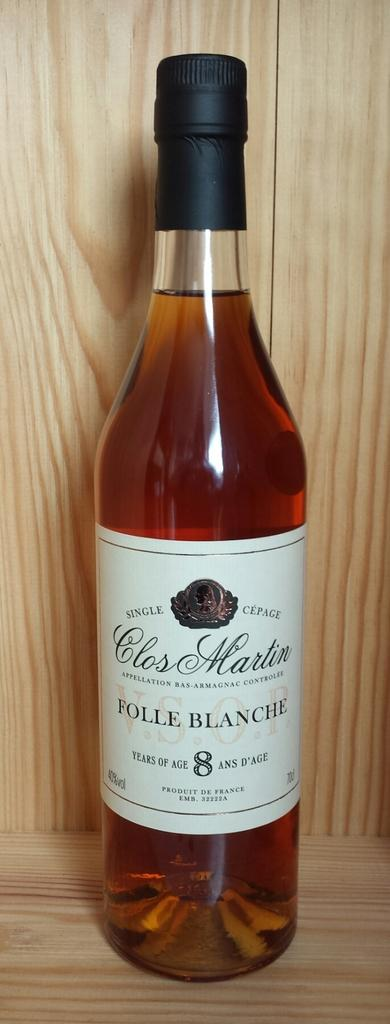<image>
Summarize the visual content of the image. A bottle of wine says Folle Blanche on the label and is on a wooden shelf. 